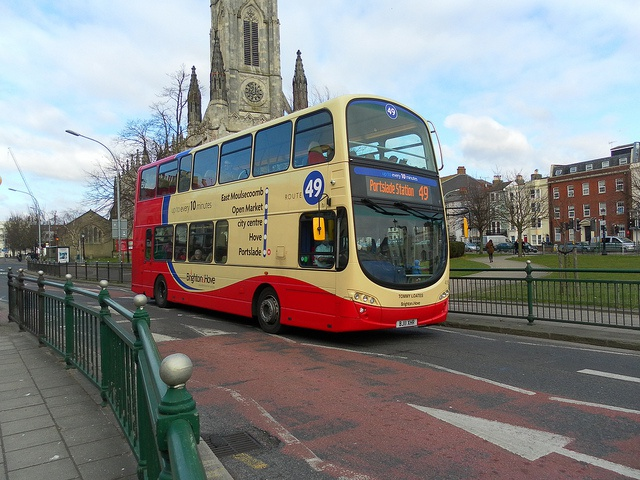Describe the objects in this image and their specific colors. I can see bus in lightblue, black, gray, tan, and brown tones, car in lightblue, gray, black, darkgray, and purple tones, people in lightblue, black, and teal tones, clock in lightblue, gray, darkgray, and black tones, and people in lightblue, gray, and teal tones in this image. 